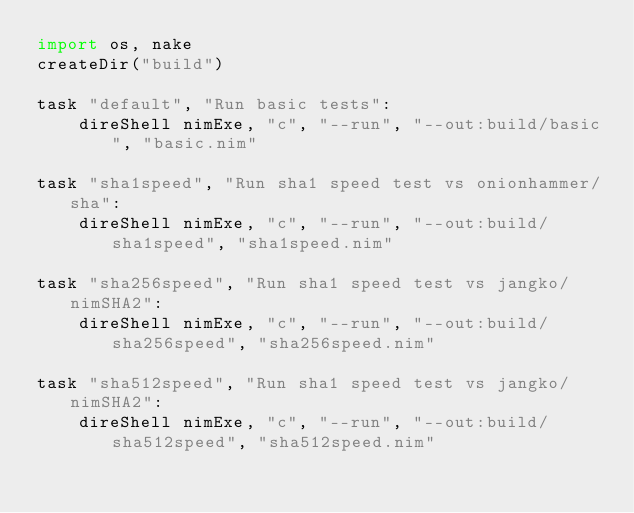Convert code to text. <code><loc_0><loc_0><loc_500><loc_500><_Nim_>import os, nake
createDir("build")

task "default", "Run basic tests":
    direShell nimExe, "c", "--run", "--out:build/basic", "basic.nim"

task "sha1speed", "Run sha1 speed test vs onionhammer/sha":
    direShell nimExe, "c", "--run", "--out:build/sha1speed", "sha1speed.nim"

task "sha256speed", "Run sha1 speed test vs jangko/nimSHA2":
    direShell nimExe, "c", "--run", "--out:build/sha256speed", "sha256speed.nim"

task "sha512speed", "Run sha1 speed test vs jangko/nimSHA2":
    direShell nimExe, "c", "--run", "--out:build/sha512speed", "sha512speed.nim"</code> 